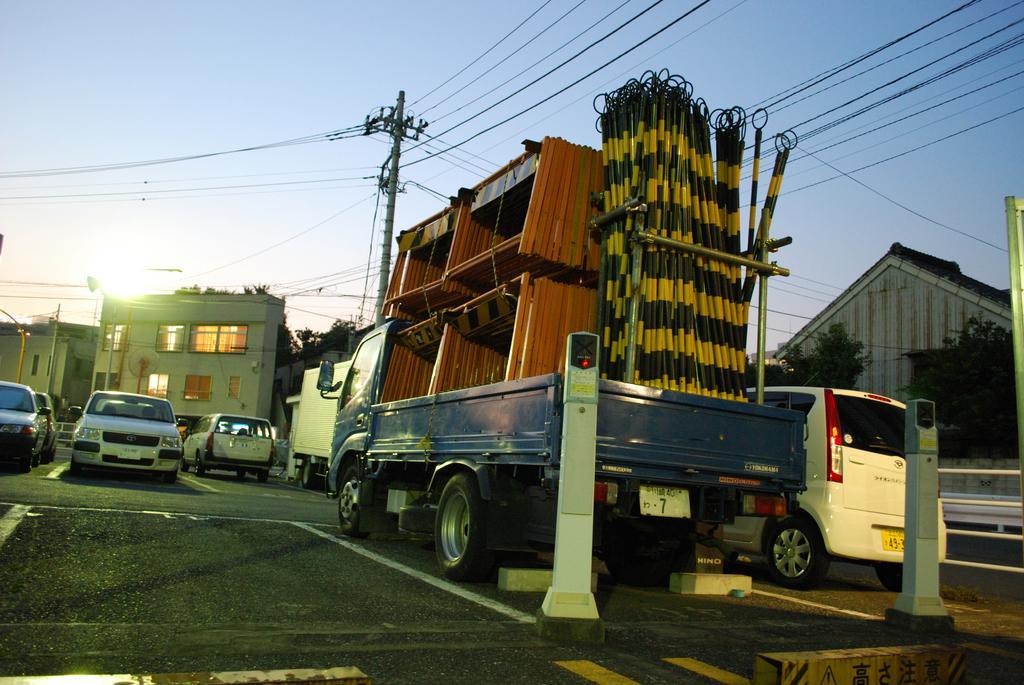Please provide a concise description of this image. Vehicles are on the road. This is current pole. Background there are buildings, sky and trees. To this building there are windows. In this vehicle there are things. These are parking meters. 